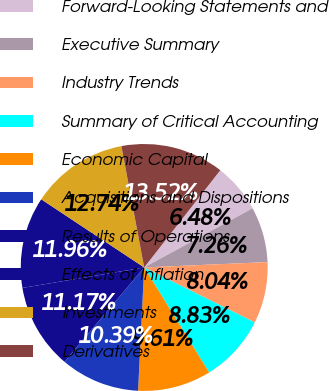Convert chart to OTSL. <chart><loc_0><loc_0><loc_500><loc_500><pie_chart><fcel>Forward-Looking Statements and<fcel>Executive Summary<fcel>Industry Trends<fcel>Summary of Critical Accounting<fcel>Economic Capital<fcel>Acquisitions and Dispositions<fcel>Results of Operations<fcel>Effects of Inflation<fcel>Investments<fcel>Derivatives<nl><fcel>6.48%<fcel>7.26%<fcel>8.04%<fcel>8.83%<fcel>9.61%<fcel>10.39%<fcel>11.17%<fcel>11.96%<fcel>12.74%<fcel>13.52%<nl></chart> 